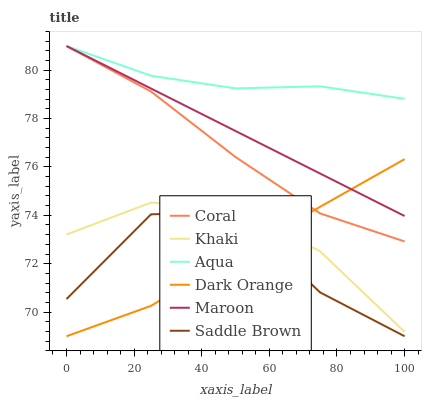Does Khaki have the minimum area under the curve?
Answer yes or no. No. Does Khaki have the maximum area under the curve?
Answer yes or no. No. Is Khaki the smoothest?
Answer yes or no. No. Is Khaki the roughest?
Answer yes or no. No. Does Khaki have the lowest value?
Answer yes or no. No. Does Khaki have the highest value?
Answer yes or no. No. Is Saddle Brown less than Maroon?
Answer yes or no. Yes. Is Coral greater than Saddle Brown?
Answer yes or no. Yes. Does Saddle Brown intersect Maroon?
Answer yes or no. No. 